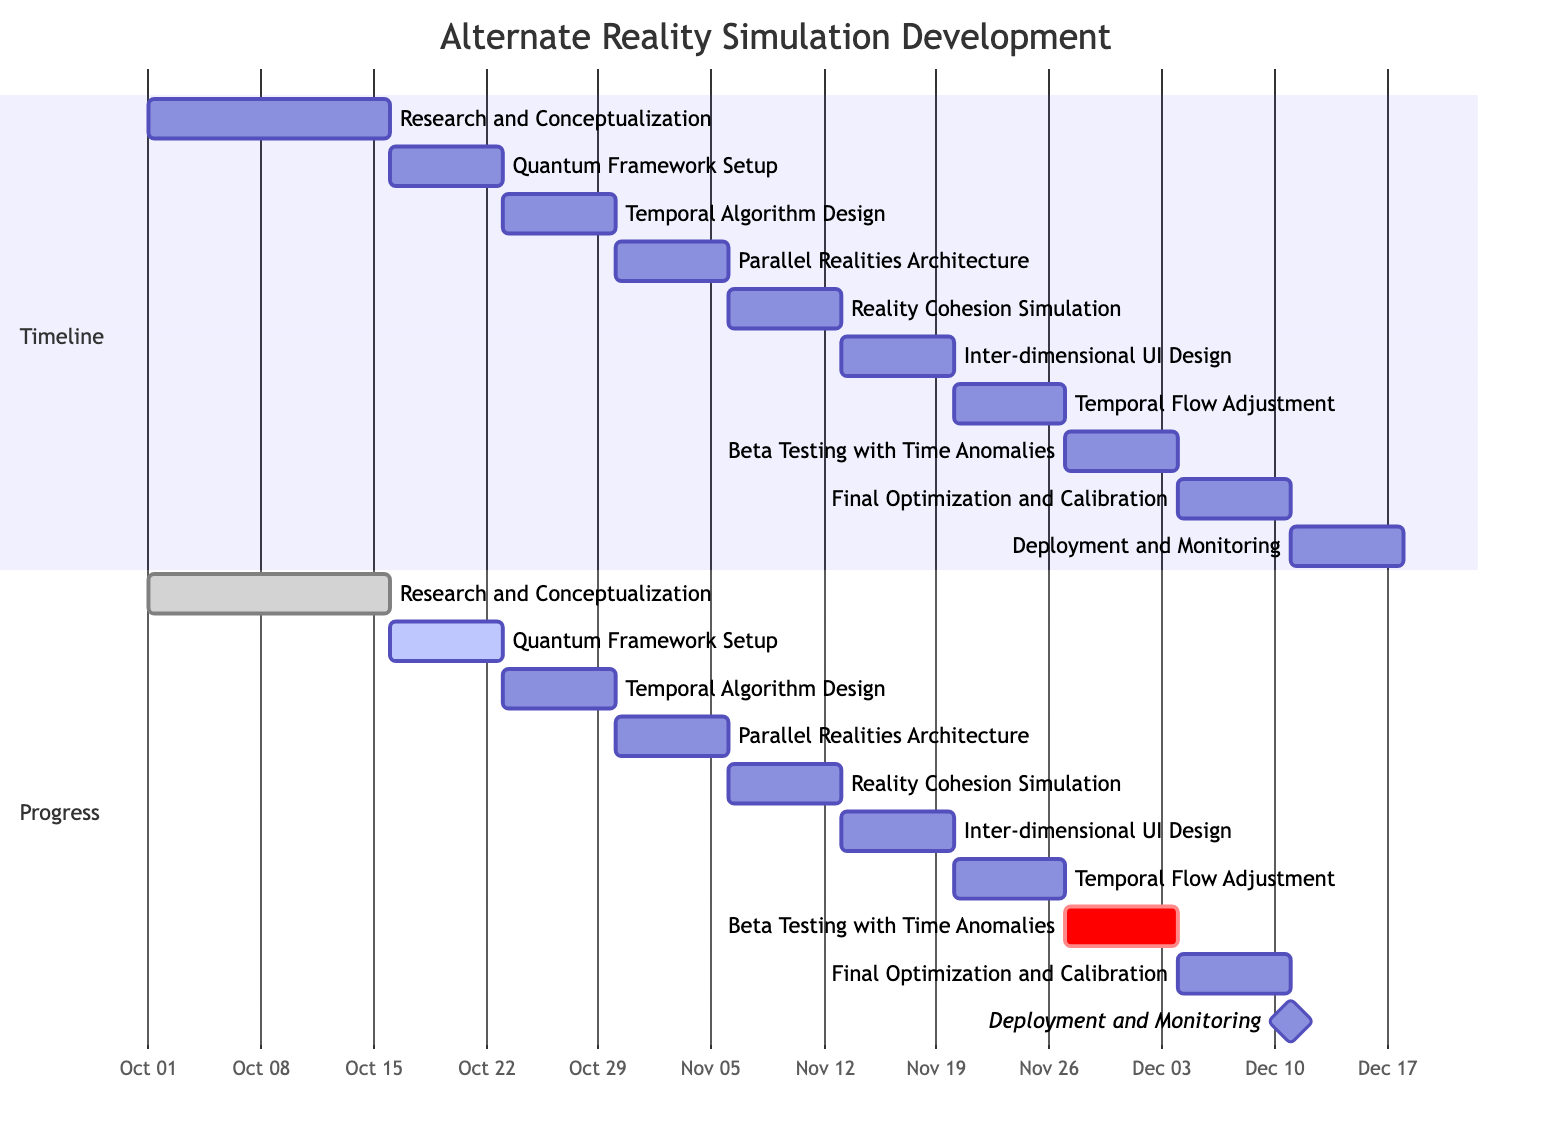What is the total number of tasks in the development process? By counting each task listed in the data, there are 10 distinct tasks within the timeline of the Gantt chart.
Answer: 10 Which task begins immediately after "Research and Conceptualization"? The dependencies specify that "Quantum Framework Setup" follows directly after the completion of "Research and Conceptualization."
Answer: Quantum Framework Setup What is the end date for "Temporal Algorithm Design"? The end date is explicitly stated in the data, indicating that it concludes on "2023-10-29."
Answer: 2023-10-29 How many days is allocated for "Reality Cohesion Simulation"? According to the start and end dates provided, "Reality Cohesion Simulation" spans a duration of 7 days.
Answer: 7 days Which task has the status "critical"? The "Beta Testing with Time Anomalies" task is designated with a "critical" status in the progress section, indicating its importance in the timeline.
Answer: Beta Testing with Time Anomalies What task is designated as the milestone in this Gantt chart? The milestone status is assigned to "Deployment and Monitoring," marking it as a significant phase in the project timeline.
Answer: Deployment and Monitoring What task follows "Temporal Flow Adjustment"? According to the dependency structure, "Beta Testing with Time Anomalies" comes next after "Temporal Flow Adjustment."
Answer: Beta Testing with Time Anomalies How many tasks are scheduled after "Inter-dimensional User Interface Design"? There are three tasks scheduled after "Inter-dimensional User Interface Design": "Temporal Flow Adjustment," "Beta Testing with Time Anomalies," and "Final Optimization and Calibration."
Answer: 3 What is the start date of "Quantum Framework Setup"? The start date is detailed in the data, indicating that "Quantum Framework Setup" begins on "2023-10-16."
Answer: 2023-10-16 